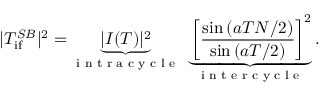Convert formula to latex. <formula><loc_0><loc_0><loc_500><loc_500>| T _ { { i f } } ^ { S B } | ^ { 2 } = \underbrace { | I ( T ) | ^ { 2 } } _ { i n t r a c y c l e } \underbrace { \left [ \frac { \sin { ( a T N / 2 ) } } { \sin { ( a T / 2 ) } } \right ] ^ { 2 } } _ { i n t e r c y c l e } .</formula> 